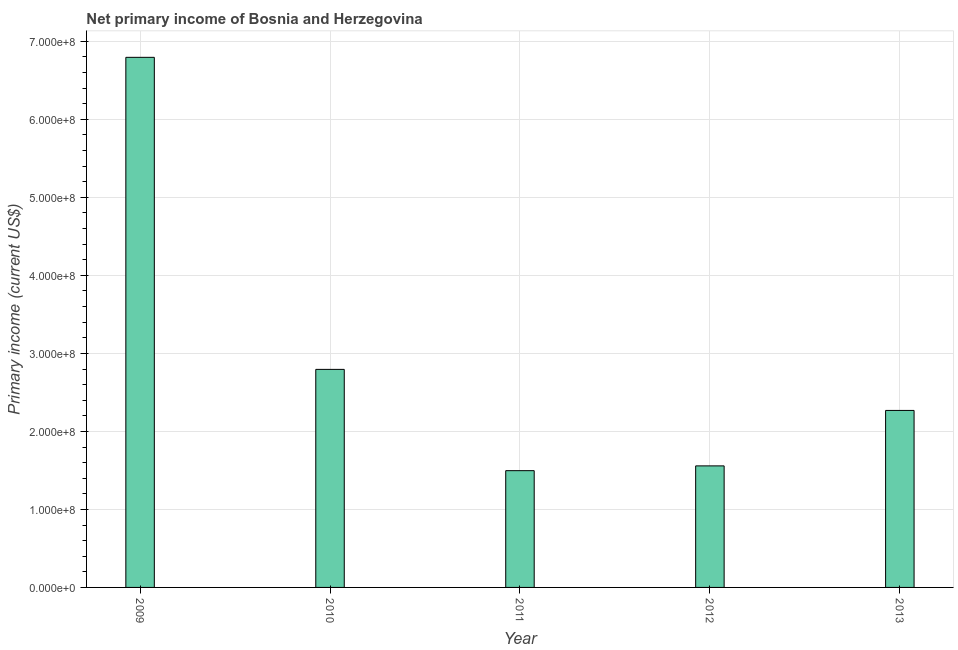Does the graph contain grids?
Offer a very short reply. Yes. What is the title of the graph?
Give a very brief answer. Net primary income of Bosnia and Herzegovina. What is the label or title of the Y-axis?
Provide a short and direct response. Primary income (current US$). What is the amount of primary income in 2009?
Ensure brevity in your answer.  6.80e+08. Across all years, what is the maximum amount of primary income?
Make the answer very short. 6.80e+08. Across all years, what is the minimum amount of primary income?
Give a very brief answer. 1.50e+08. In which year was the amount of primary income maximum?
Ensure brevity in your answer.  2009. In which year was the amount of primary income minimum?
Your response must be concise. 2011. What is the sum of the amount of primary income?
Offer a terse response. 1.49e+09. What is the difference between the amount of primary income in 2012 and 2013?
Make the answer very short. -7.11e+07. What is the average amount of primary income per year?
Ensure brevity in your answer.  2.98e+08. What is the median amount of primary income?
Give a very brief answer. 2.27e+08. Do a majority of the years between 2009 and 2012 (inclusive) have amount of primary income greater than 240000000 US$?
Provide a succinct answer. No. What is the ratio of the amount of primary income in 2010 to that in 2011?
Keep it short and to the point. 1.87. Is the amount of primary income in 2009 less than that in 2011?
Ensure brevity in your answer.  No. Is the difference between the amount of primary income in 2010 and 2013 greater than the difference between any two years?
Your answer should be very brief. No. What is the difference between the highest and the second highest amount of primary income?
Provide a short and direct response. 4.00e+08. Is the sum of the amount of primary income in 2009 and 2011 greater than the maximum amount of primary income across all years?
Make the answer very short. Yes. What is the difference between the highest and the lowest amount of primary income?
Provide a short and direct response. 5.30e+08. In how many years, is the amount of primary income greater than the average amount of primary income taken over all years?
Your answer should be compact. 1. Are all the bars in the graph horizontal?
Your answer should be compact. No. What is the difference between two consecutive major ticks on the Y-axis?
Provide a succinct answer. 1.00e+08. What is the Primary income (current US$) in 2009?
Make the answer very short. 6.80e+08. What is the Primary income (current US$) of 2010?
Make the answer very short. 2.80e+08. What is the Primary income (current US$) of 2011?
Give a very brief answer. 1.50e+08. What is the Primary income (current US$) of 2012?
Your answer should be compact. 1.56e+08. What is the Primary income (current US$) of 2013?
Provide a succinct answer. 2.27e+08. What is the difference between the Primary income (current US$) in 2009 and 2010?
Offer a terse response. 4.00e+08. What is the difference between the Primary income (current US$) in 2009 and 2011?
Make the answer very short. 5.30e+08. What is the difference between the Primary income (current US$) in 2009 and 2012?
Provide a short and direct response. 5.24e+08. What is the difference between the Primary income (current US$) in 2009 and 2013?
Offer a terse response. 4.53e+08. What is the difference between the Primary income (current US$) in 2010 and 2011?
Offer a terse response. 1.30e+08. What is the difference between the Primary income (current US$) in 2010 and 2012?
Your answer should be very brief. 1.24e+08. What is the difference between the Primary income (current US$) in 2010 and 2013?
Keep it short and to the point. 5.26e+07. What is the difference between the Primary income (current US$) in 2011 and 2012?
Your answer should be very brief. -6.13e+06. What is the difference between the Primary income (current US$) in 2011 and 2013?
Your answer should be very brief. -7.72e+07. What is the difference between the Primary income (current US$) in 2012 and 2013?
Your answer should be very brief. -7.11e+07. What is the ratio of the Primary income (current US$) in 2009 to that in 2010?
Provide a succinct answer. 2.43. What is the ratio of the Primary income (current US$) in 2009 to that in 2011?
Your response must be concise. 4.54. What is the ratio of the Primary income (current US$) in 2009 to that in 2012?
Give a very brief answer. 4.36. What is the ratio of the Primary income (current US$) in 2009 to that in 2013?
Your answer should be compact. 3. What is the ratio of the Primary income (current US$) in 2010 to that in 2011?
Your answer should be very brief. 1.87. What is the ratio of the Primary income (current US$) in 2010 to that in 2012?
Give a very brief answer. 1.79. What is the ratio of the Primary income (current US$) in 2010 to that in 2013?
Provide a short and direct response. 1.23. What is the ratio of the Primary income (current US$) in 2011 to that in 2012?
Your answer should be very brief. 0.96. What is the ratio of the Primary income (current US$) in 2011 to that in 2013?
Make the answer very short. 0.66. What is the ratio of the Primary income (current US$) in 2012 to that in 2013?
Offer a terse response. 0.69. 